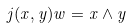<formula> <loc_0><loc_0><loc_500><loc_500>j ( x , y ) w = x \wedge y</formula> 